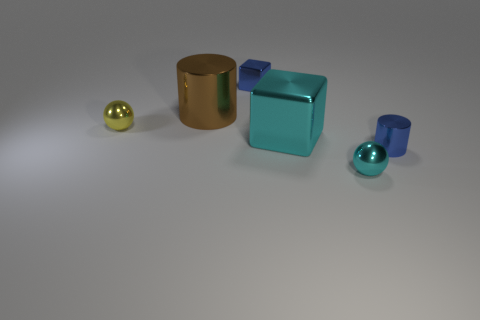Is the tiny sphere in front of the small shiny cylinder made of the same material as the cube to the left of the large cyan metal thing? Yes, the tiny golden sphere and the larger cube both appear to have a similar reflective metallic finish, indicating that they could likely be made of the same or similar materials. 